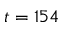Convert formula to latex. <formula><loc_0><loc_0><loc_500><loc_500>t = 1 5 4</formula> 